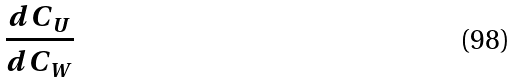Convert formula to latex. <formula><loc_0><loc_0><loc_500><loc_500>\frac { d C _ { U } } { d C _ { W } }</formula> 